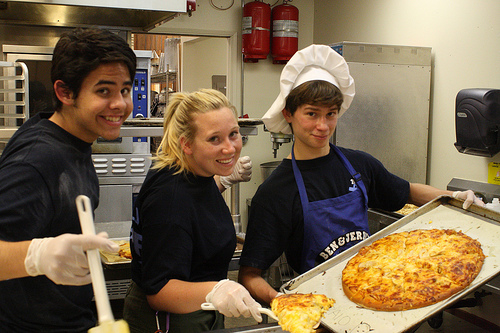How many people are in this picture? 3 